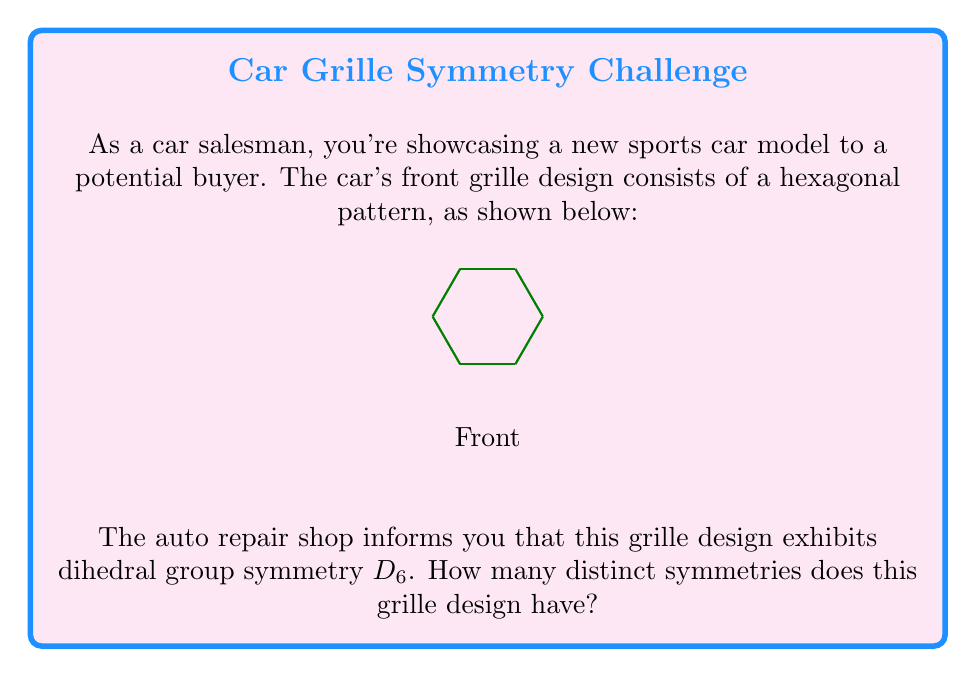Solve this math problem. To solve this problem, we need to understand the properties of the dihedral group $D_6$ and count its elements:

1) The dihedral group $D_n$ is the group of symmetries of a regular n-gon. In this case, we have $D_6$ for a hexagon.

2) The order of $D_n$ is given by the formula $|D_n| = 2n$. This is because $D_n$ includes:
   - $n$ rotational symmetries (including the identity)
   - $n$ reflection symmetries

3) For $D_6$, we have:
   $|D_6| = 2 \cdot 6 = 12$

4) These 12 symmetries can be broken down as follows:
   - 6 rotational symmetries: rotations by $0°, 60°, 120°, 180°, 240°, 300°$
   - 6 reflection symmetries: reflections across the 3 diagonals and 3 lines connecting opposite sides

Therefore, the grille design with $D_6$ symmetry has 12 distinct symmetries.
Answer: 12 